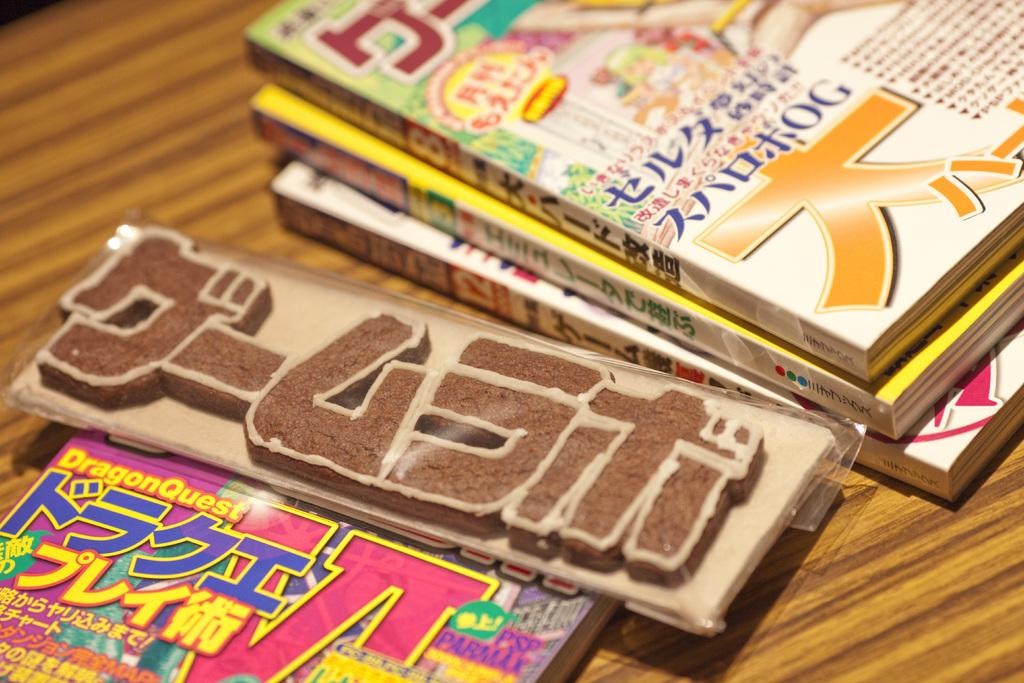<image>
Present a compact description of the photo's key features. Japanese comic books sit on a table, one of which is DragonQuest. 